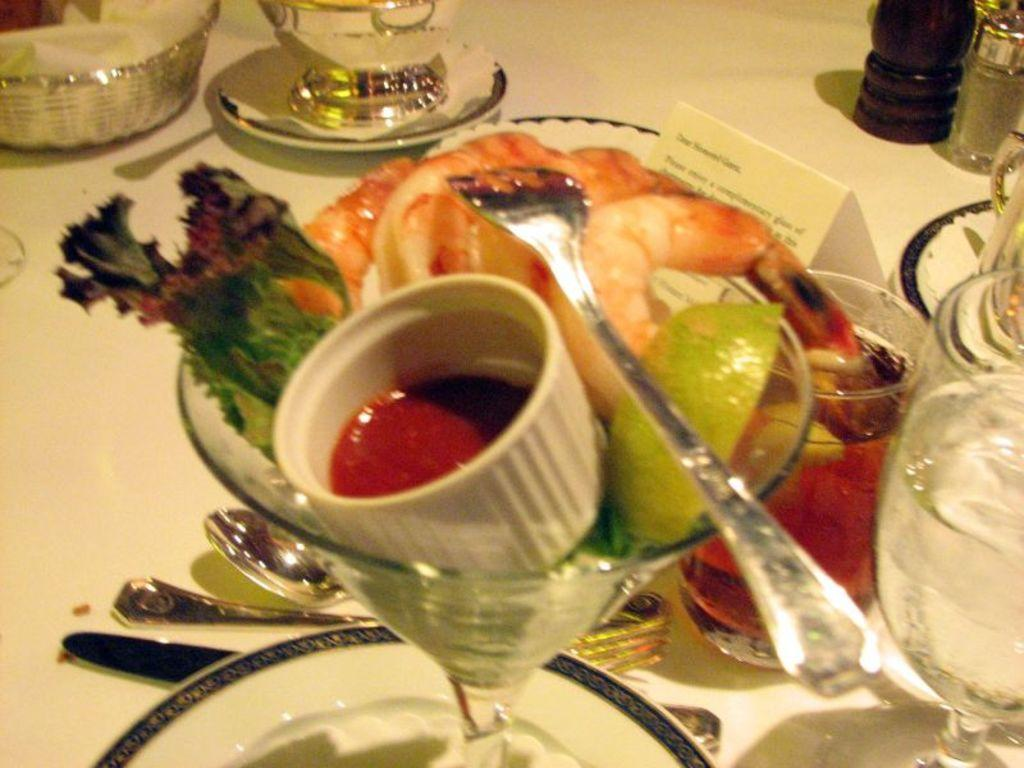What is on the plate that is visible in the image? There is a plate with prawns in the image. What accompanies the prawns on the plate? There is a bowl of sauce in the image. What utensil is visible in the image? A fork is visible in the image. What type of beverage is present in the image? There are glasses of water in the image. What other utensils can be seen on the table in the image? There are spoons on the table in the image. What type of balls are being used for conditioning the prawns in the image? There are no balls present in the image, and prawns do not require conditioning. 